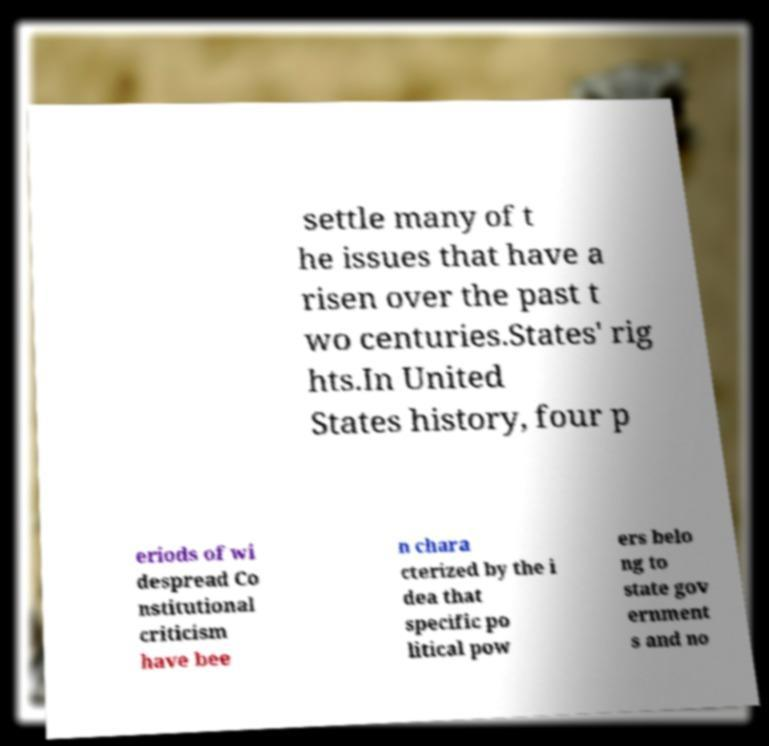I need the written content from this picture converted into text. Can you do that? settle many of t he issues that have a risen over the past t wo centuries.States' rig hts.In United States history, four p eriods of wi despread Co nstitutional criticism have bee n chara cterized by the i dea that specific po litical pow ers belo ng to state gov ernment s and no 